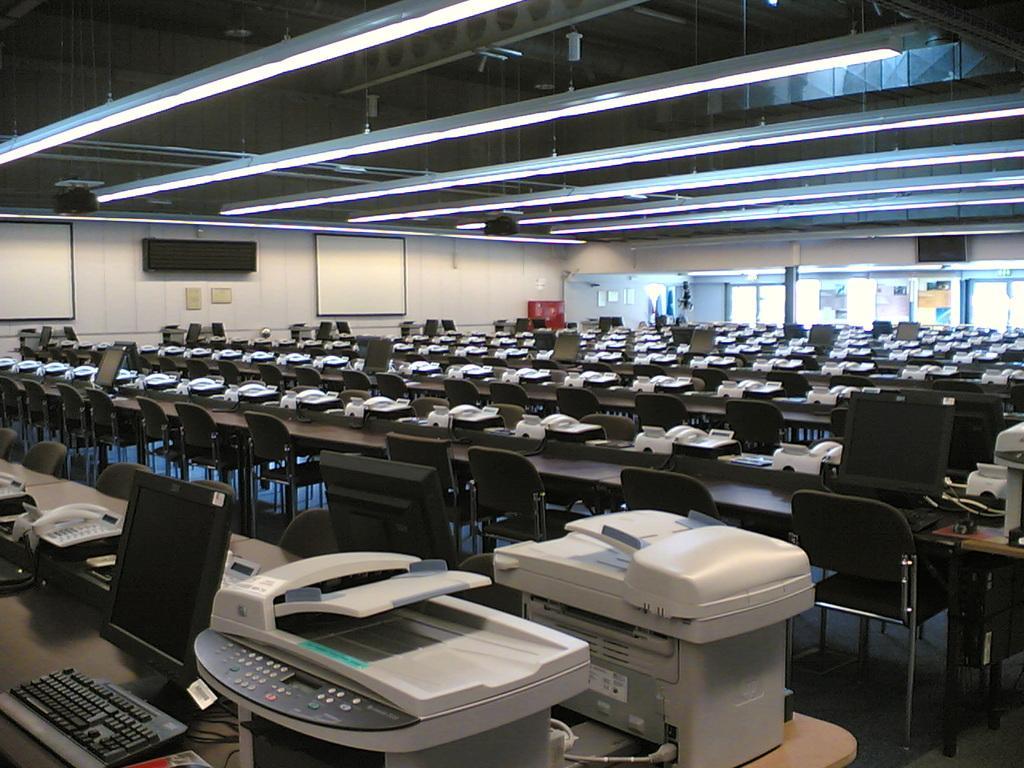Describe this image in one or two sentences. In the picture we can see a hall with tables, chairs and some printing machines and typing machines, fax machines and we can also see a monitor, keyboards, telephones. In the background we can see a white board on the walls and to the ceiling we can see a light. 